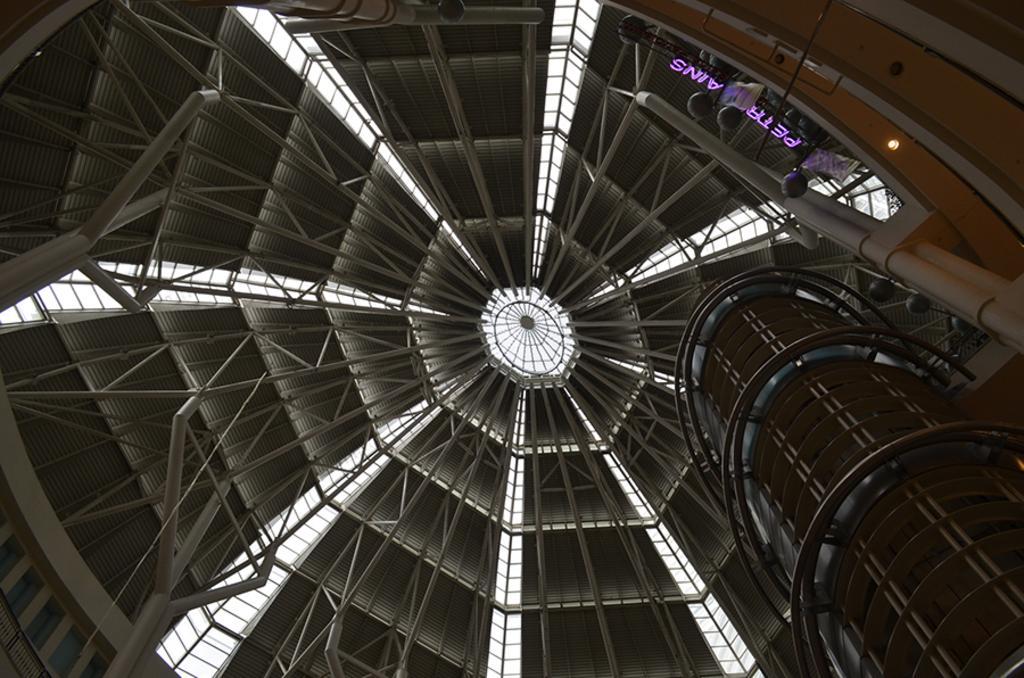Could you give a brief overview of what you see in this image? In this image I can see a rooftop, metal rods, lights and a building. This image is taken may be in a building. 